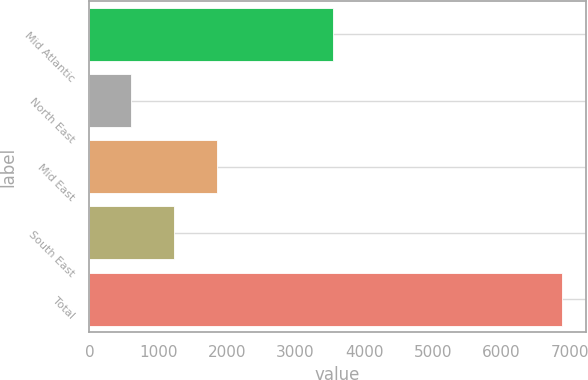Convert chart. <chart><loc_0><loc_0><loc_500><loc_500><bar_chart><fcel>Mid Atlantic<fcel>North East<fcel>Mid East<fcel>South East<fcel>Total<nl><fcel>3541<fcel>608<fcel>1863.6<fcel>1236<fcel>6884<nl></chart> 